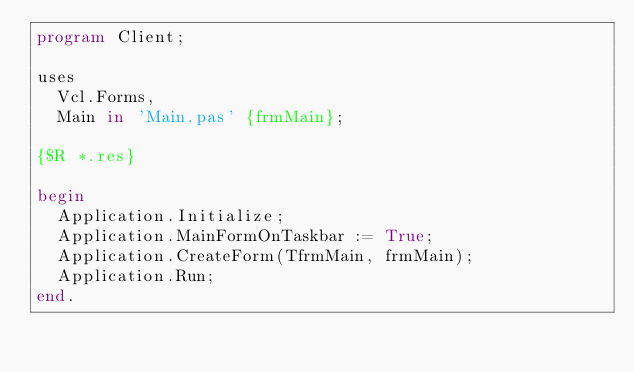<code> <loc_0><loc_0><loc_500><loc_500><_Pascal_>program Client;

uses
  Vcl.Forms,
  Main in 'Main.pas' {frmMain};

{$R *.res}

begin
  Application.Initialize;
  Application.MainFormOnTaskbar := True;
  Application.CreateForm(TfrmMain, frmMain);
  Application.Run;
end.
</code> 